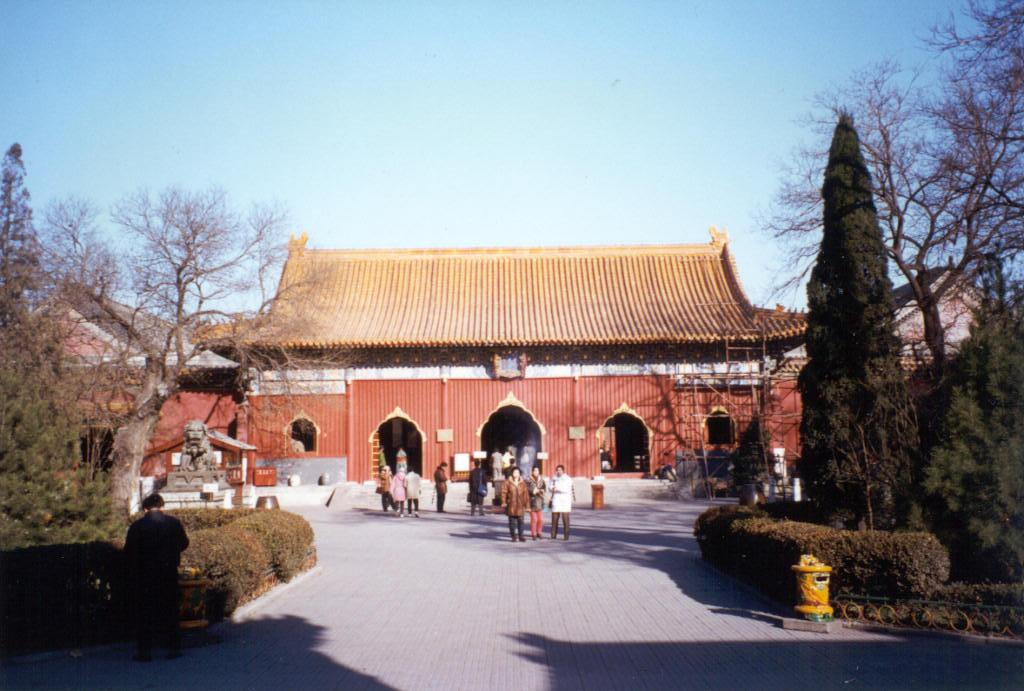What are the people in the image doing? The persons in the image are standing on a surface. What type of natural elements can be seen in the image? There are trees and plants in the image. What man-made structures are visible in the image? There are houses, poles, and roofs in the image. What is the statue on a platform in the image? There is a statue on a platform in the image. What is visible in the sky in the image? The sky is visible in the image. What type of watch can be seen on the statue's wrist in the image? There is no watch visible on the statue's wrist in the image. What is the source of the surprise in the image? There is no indication of a surprise in the image. 